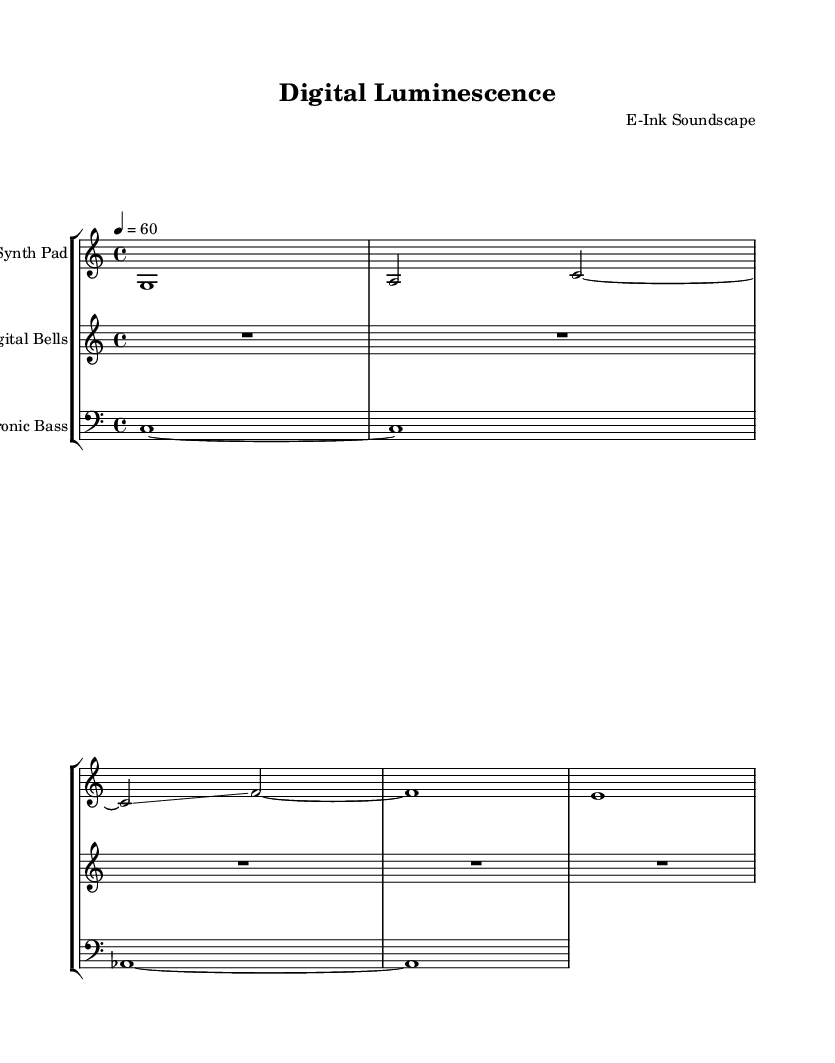What is the title of this music? The title is indicated at the top of the sheet music, under the header section.
Answer: Digital Luminescence What is the tempo marking in the piece? The tempo marking can be found in the global section, where it specifies "4 = 60", indicating the beats per minute.
Answer: 60 What is the time signature of this music? The time signature is also provided in the global section, denoted as "4/4", which is a common time signature indicating four beats per measure.
Answer: 4/4 How many staves are present in this score? The score contains three staves, each representing a different instrument, as indicated by the group of staves in the score layout.
Answer: Three What is unique about the rest notation in "Digital Bells"? The "Digital Bells" part uses a whole rest (R1*5), indicating a five-measure silence, which is a distinctive feature of ambient music that emphasizes space over sound.
Answer: Whole rest Which clef is used for the "Electronic Bass"? The clef used for the "Electronic Bass" is the bass clef, which is indicated at the beginning of the staff for that part.
Answer: Bass clef What performance technique is indicated for the "synthPad"? The notation includes a glissando (represented by the tilde symbol) in the "synthPad", a technique common in electronic and ambient music allowing for smooth transitions between notes.
Answer: Glissando 